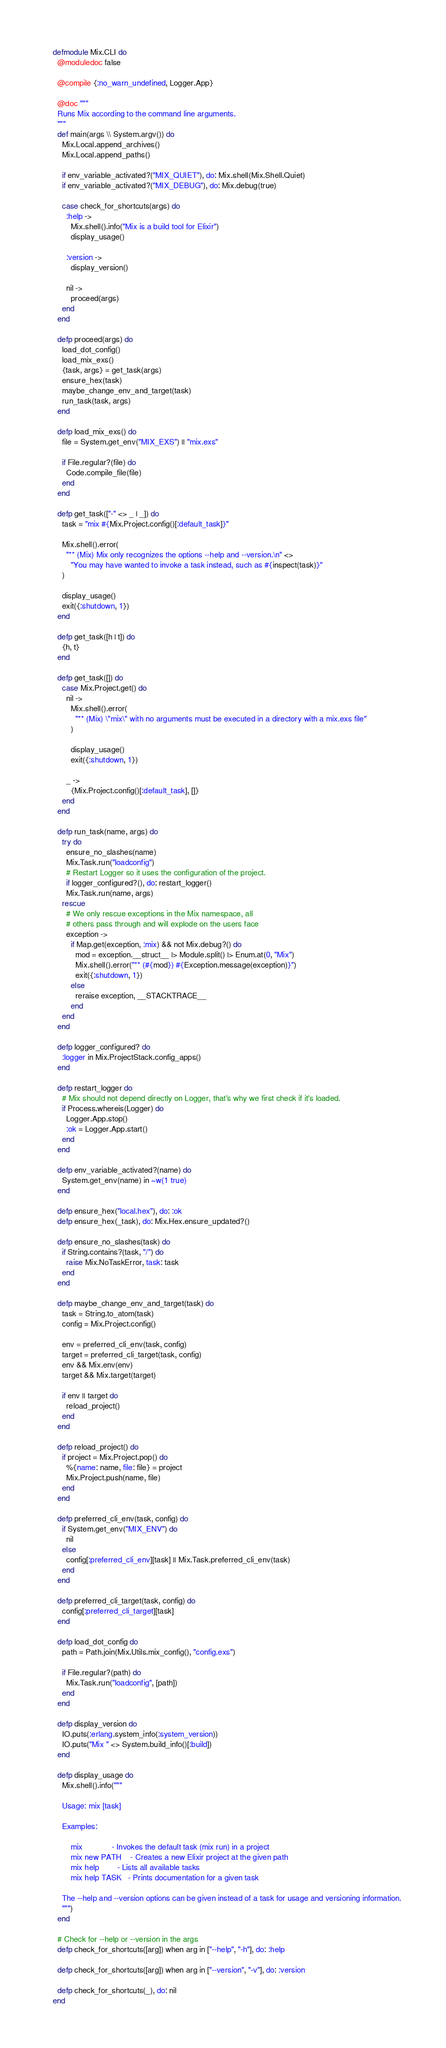Convert code to text. <code><loc_0><loc_0><loc_500><loc_500><_Elixir_>defmodule Mix.CLI do
  @moduledoc false

  @compile {:no_warn_undefined, Logger.App}

  @doc """
  Runs Mix according to the command line arguments.
  """
  def main(args \\ System.argv()) do
    Mix.Local.append_archives()
    Mix.Local.append_paths()

    if env_variable_activated?("MIX_QUIET"), do: Mix.shell(Mix.Shell.Quiet)
    if env_variable_activated?("MIX_DEBUG"), do: Mix.debug(true)

    case check_for_shortcuts(args) do
      :help ->
        Mix.shell().info("Mix is a build tool for Elixir")
        display_usage()

      :version ->
        display_version()

      nil ->
        proceed(args)
    end
  end

  defp proceed(args) do
    load_dot_config()
    load_mix_exs()
    {task, args} = get_task(args)
    ensure_hex(task)
    maybe_change_env_and_target(task)
    run_task(task, args)
  end

  defp load_mix_exs() do
    file = System.get_env("MIX_EXS") || "mix.exs"

    if File.regular?(file) do
      Code.compile_file(file)
    end
  end

  defp get_task(["-" <> _ | _]) do
    task = "mix #{Mix.Project.config()[:default_task]}"

    Mix.shell().error(
      "** (Mix) Mix only recognizes the options --help and --version.\n" <>
        "You may have wanted to invoke a task instead, such as #{inspect(task)}"
    )

    display_usage()
    exit({:shutdown, 1})
  end

  defp get_task([h | t]) do
    {h, t}
  end

  defp get_task([]) do
    case Mix.Project.get() do
      nil ->
        Mix.shell().error(
          "** (Mix) \"mix\" with no arguments must be executed in a directory with a mix.exs file"
        )

        display_usage()
        exit({:shutdown, 1})

      _ ->
        {Mix.Project.config()[:default_task], []}
    end
  end

  defp run_task(name, args) do
    try do
      ensure_no_slashes(name)
      Mix.Task.run("loadconfig")
      # Restart Logger so it uses the configuration of the project.
      if logger_configured?(), do: restart_logger()
      Mix.Task.run(name, args)
    rescue
      # We only rescue exceptions in the Mix namespace, all
      # others pass through and will explode on the users face
      exception ->
        if Map.get(exception, :mix) && not Mix.debug?() do
          mod = exception.__struct__ |> Module.split() |> Enum.at(0, "Mix")
          Mix.shell().error("** (#{mod}) #{Exception.message(exception)}")
          exit({:shutdown, 1})
        else
          reraise exception, __STACKTRACE__
        end
    end
  end

  defp logger_configured? do
    :logger in Mix.ProjectStack.config_apps()
  end

  defp restart_logger do
    # Mix should not depend directly on Logger, that's why we first check if it's loaded.
    if Process.whereis(Logger) do
      Logger.App.stop()
      :ok = Logger.App.start()
    end
  end

  defp env_variable_activated?(name) do
    System.get_env(name) in ~w(1 true)
  end

  defp ensure_hex("local.hex"), do: :ok
  defp ensure_hex(_task), do: Mix.Hex.ensure_updated?()

  defp ensure_no_slashes(task) do
    if String.contains?(task, "/") do
      raise Mix.NoTaskError, task: task
    end
  end

  defp maybe_change_env_and_target(task) do
    task = String.to_atom(task)
    config = Mix.Project.config()

    env = preferred_cli_env(task, config)
    target = preferred_cli_target(task, config)
    env && Mix.env(env)
    target && Mix.target(target)

    if env || target do
      reload_project()
    end
  end

  defp reload_project() do
    if project = Mix.Project.pop() do
      %{name: name, file: file} = project
      Mix.Project.push(name, file)
    end
  end

  defp preferred_cli_env(task, config) do
    if System.get_env("MIX_ENV") do
      nil
    else
      config[:preferred_cli_env][task] || Mix.Task.preferred_cli_env(task)
    end
  end

  defp preferred_cli_target(task, config) do
    config[:preferred_cli_target][task]
  end

  defp load_dot_config do
    path = Path.join(Mix.Utils.mix_config(), "config.exs")

    if File.regular?(path) do
      Mix.Task.run("loadconfig", [path])
    end
  end

  defp display_version do
    IO.puts(:erlang.system_info(:system_version))
    IO.puts("Mix " <> System.build_info()[:build])
  end

  defp display_usage do
    Mix.shell().info("""

    Usage: mix [task]

    Examples:

        mix             - Invokes the default task (mix run) in a project
        mix new PATH    - Creates a new Elixir project at the given path
        mix help        - Lists all available tasks
        mix help TASK   - Prints documentation for a given task

    The --help and --version options can be given instead of a task for usage and versioning information.
    """)
  end

  # Check for --help or --version in the args
  defp check_for_shortcuts([arg]) when arg in ["--help", "-h"], do: :help

  defp check_for_shortcuts([arg]) when arg in ["--version", "-v"], do: :version

  defp check_for_shortcuts(_), do: nil
end
</code> 